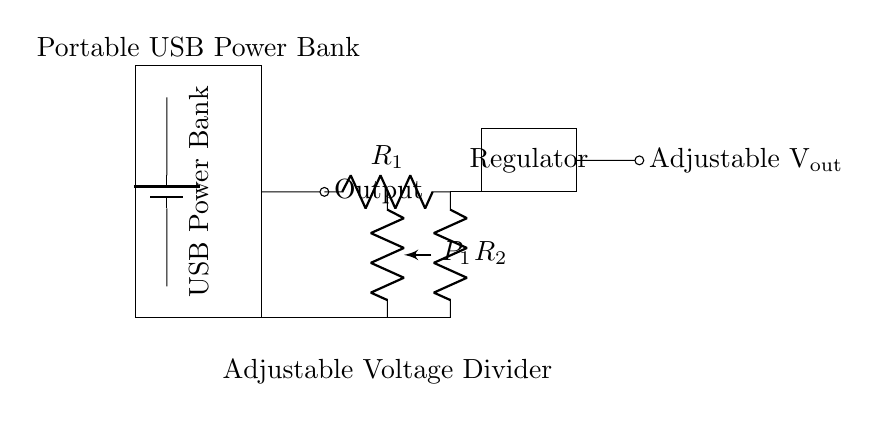What is the main component used for converting and adjusting the output voltage? The main component is a voltage regulator, as indicated in the circuit diagram. It helps ensure that the output voltage remains stable and adjustable for various devices.
Answer: Voltage regulator What are the resistors labeled in the voltage divider? The resistors in the voltage divider are labeled as R1 and R2, shown in the circuit diagram. They create the voltage division necessary for adjusting the output voltage.
Answer: R1, R2 What component allows for adjustable resistance in the circuit? The component providing adjustable resistance is the potentiometer, indicated by P1 in the diagram. This allows users to modify the resistance to change the output voltage.
Answer: Potentiometer What is the purpose of the voltage divider in this circuit? The purpose of the voltage divider is to lower the input voltage to a desired level for specific devices, achieved through the arrangement of resistors R1 and R2.
Answer: To lower the voltage How does the output voltage vary using the potentiometer? The potentiometer adjusts the voltage divider ratio, affecting how much voltage is dropped across R2, thus allowing the output voltage to be variable between preset limits depending on its position.
Answer: By changing resistance What is the input source type for this power bank? The input source type for this power bank is a battery, as it is shown in the diagram surrounded by a battery symbol, which supplies the initial voltage to the circuit.
Answer: Battery 